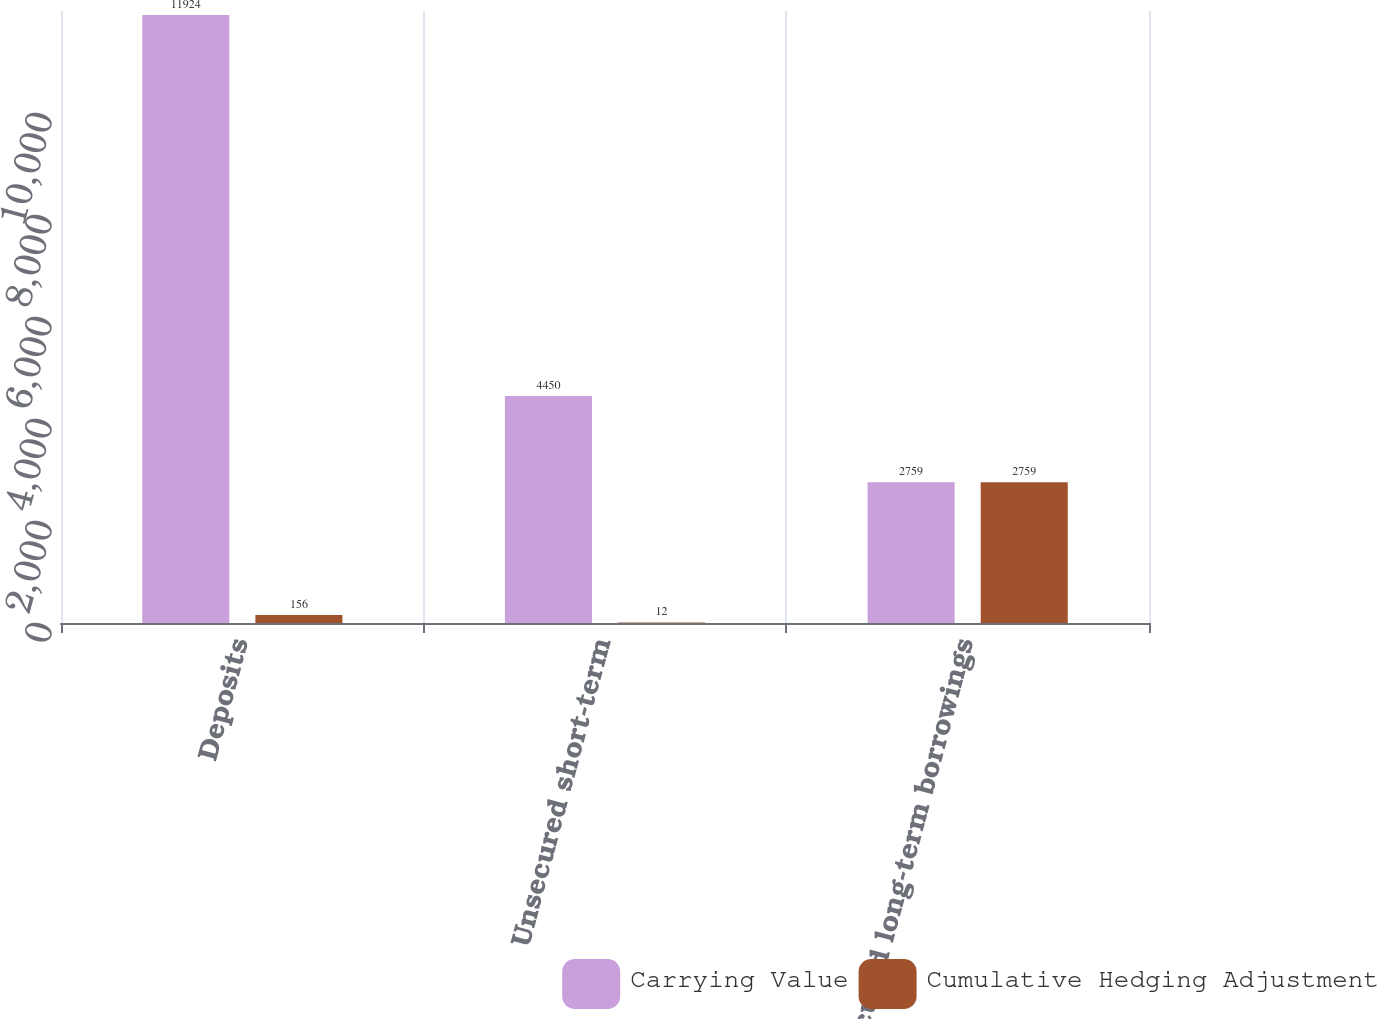Convert chart. <chart><loc_0><loc_0><loc_500><loc_500><stacked_bar_chart><ecel><fcel>Deposits<fcel>Unsecured short-term<fcel>Unsecured long-term borrowings<nl><fcel>Carrying Value<fcel>11924<fcel>4450<fcel>2759<nl><fcel>Cumulative Hedging Adjustment<fcel>156<fcel>12<fcel>2759<nl></chart> 